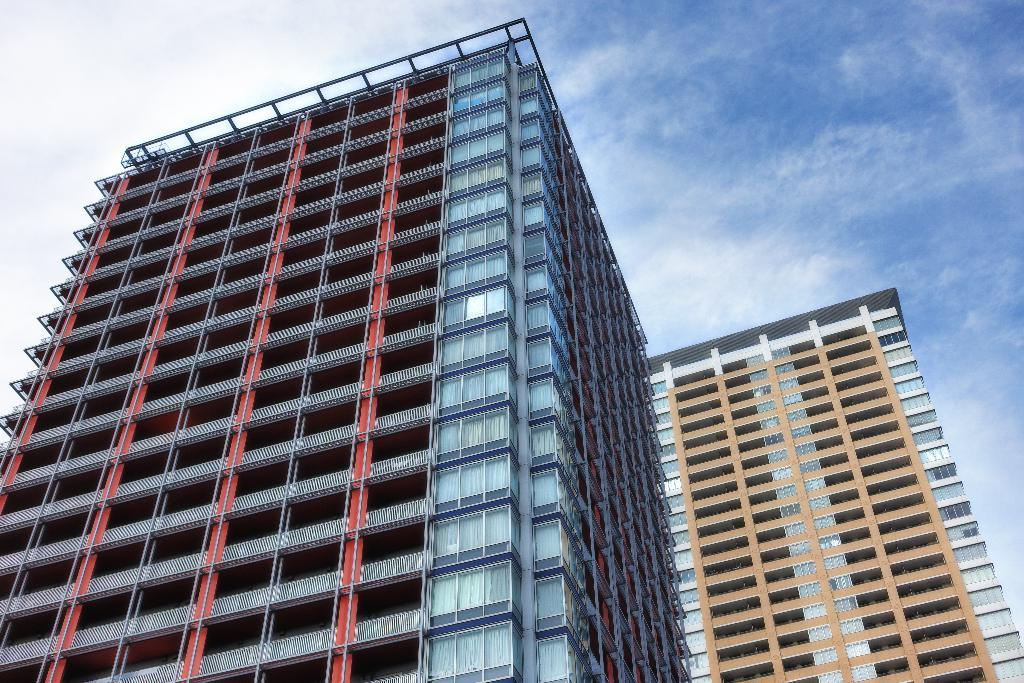What type of structures can be seen in the image? There are buildings in the image. What other objects are present in the image besides the buildings? There are metal poles in the image. What part of the natural environment is visible in the image? The sky is visible in the image. How would you describe the weather based on the appearance of the sky? The sky appears to be cloudy in the image. How many chairs are visible in the image? There are no chairs present in the image. What type of toy can be seen in the image? There are no toys present in the image. 